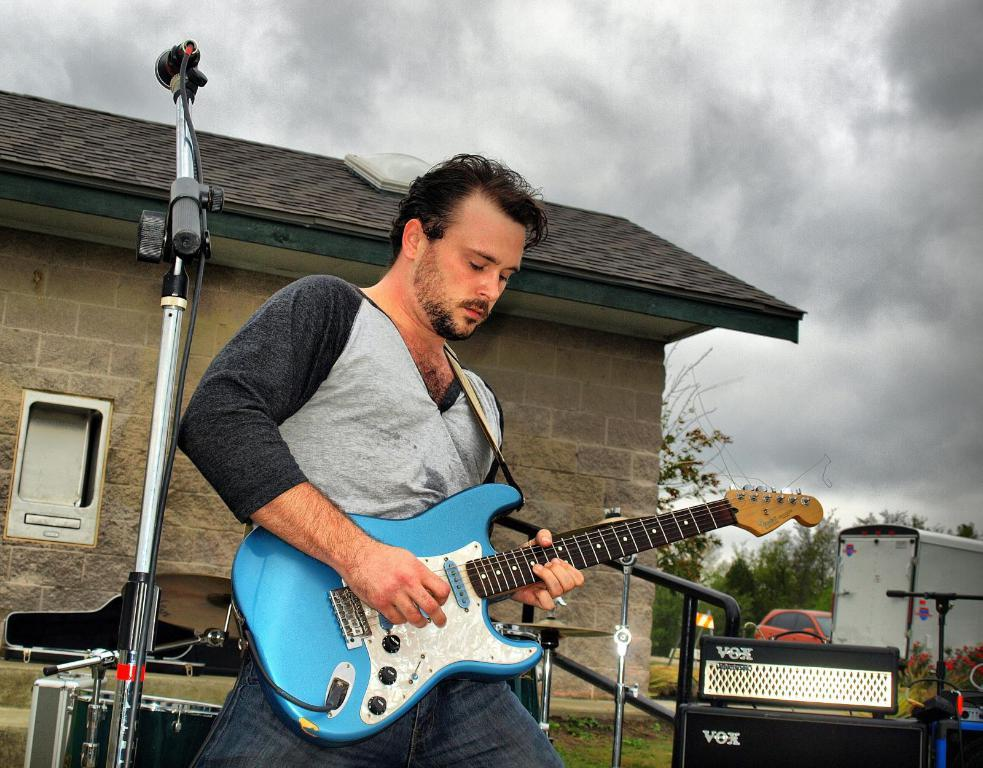What is the man in the image doing? The man is playing a guitar. What is in front of the man? There is a microphone in front of the man. What can be seen in the sky in the image? The sky is full of clouds. What is visible in the background of the image? There are vehicles, at least one building, and a window in the background of the image. What type of trouble can be seen in the alley behind the building in the image? There is no alley present in the image, and therefore no trouble can be observed. 